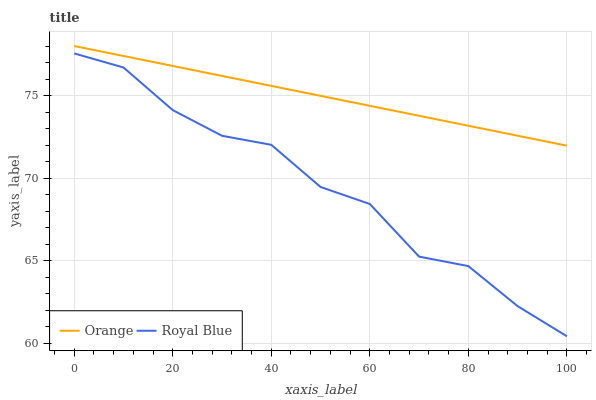Does Royal Blue have the maximum area under the curve?
Answer yes or no. No. Is Royal Blue the smoothest?
Answer yes or no. No. Does Royal Blue have the highest value?
Answer yes or no. No. Is Royal Blue less than Orange?
Answer yes or no. Yes. Is Orange greater than Royal Blue?
Answer yes or no. Yes. Does Royal Blue intersect Orange?
Answer yes or no. No. 